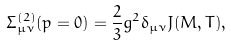Convert formula to latex. <formula><loc_0><loc_0><loc_500><loc_500>\Sigma _ { \mu \nu } ^ { ( 2 ) } ( p = 0 ) = \frac { 2 } { 3 } g ^ { 2 } \delta _ { \mu \nu } J ( M , T ) ,</formula> 